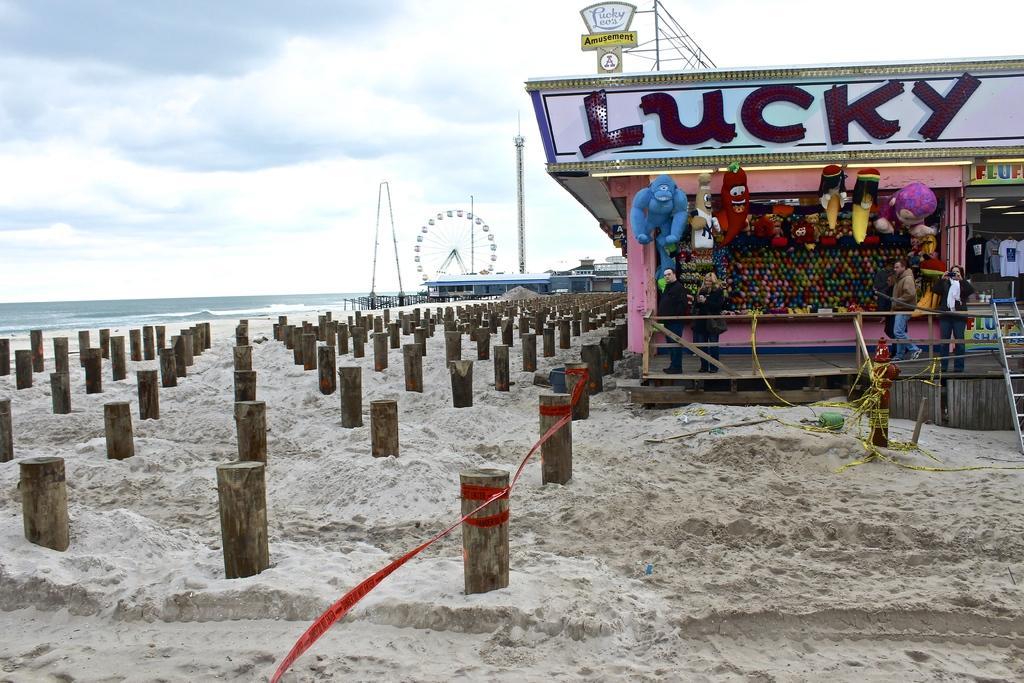How would you summarize this image in a sentence or two? This image is clicked near a beach. To the right there is a shop in which there are dolls. At the bottom, there is a sand. In the front, there are wooden sticks in the sand. To the left, there is an ocean. In the background, there is a giant wheel. At the top, there are clouds in the sky. 